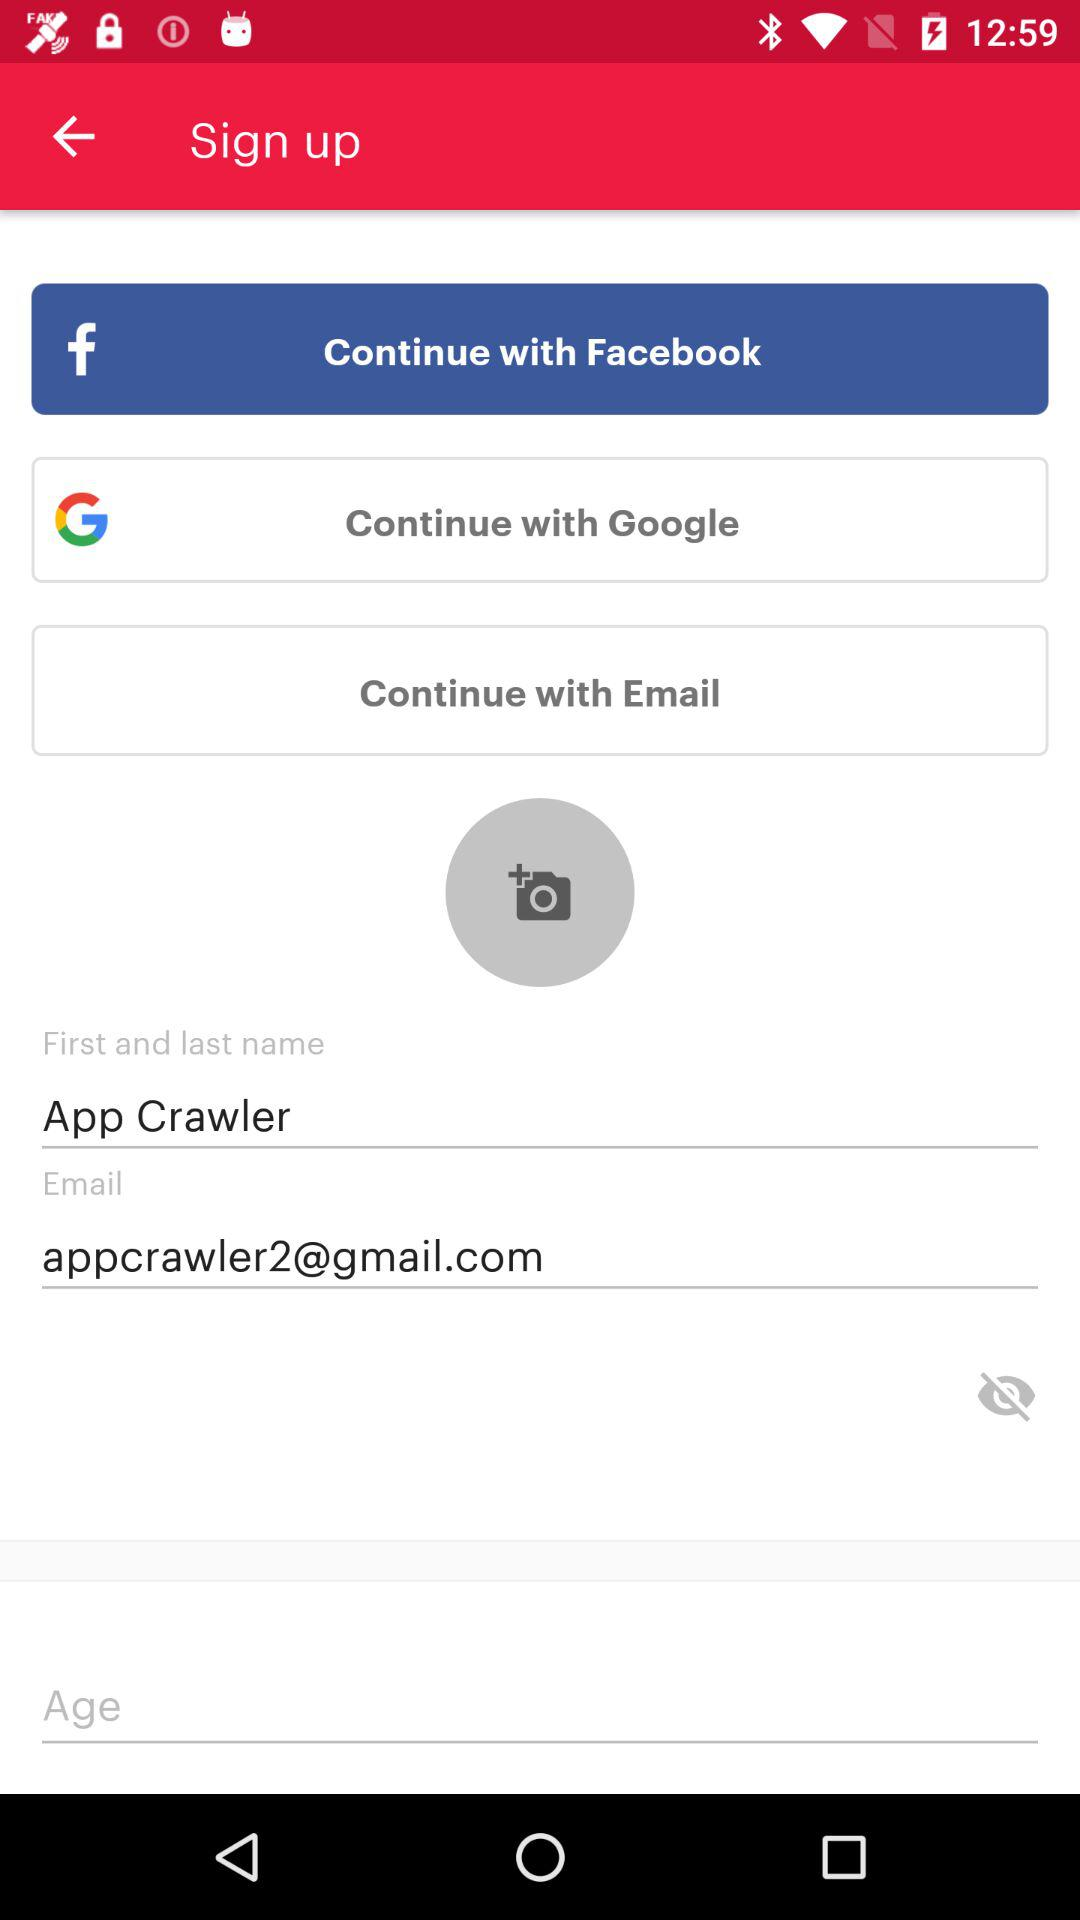What are the options do we use to sign in? The options are "Facebook", "Google", and "Email". 